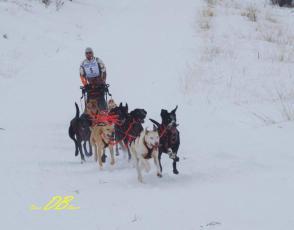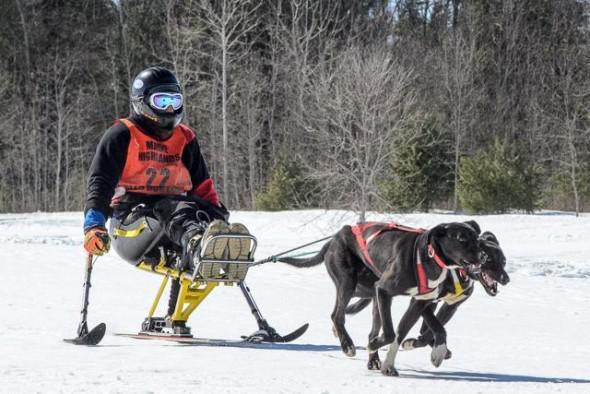The first image is the image on the left, the second image is the image on the right. Evaluate the accuracy of this statement regarding the images: "Each image shows a man in a numbered vest being pulled by a team of dogs moving forward.". Is it true? Answer yes or no. Yes. The first image is the image on the left, the second image is the image on the right. Given the left and right images, does the statement "A dog is up on its hind legs." hold true? Answer yes or no. No. 